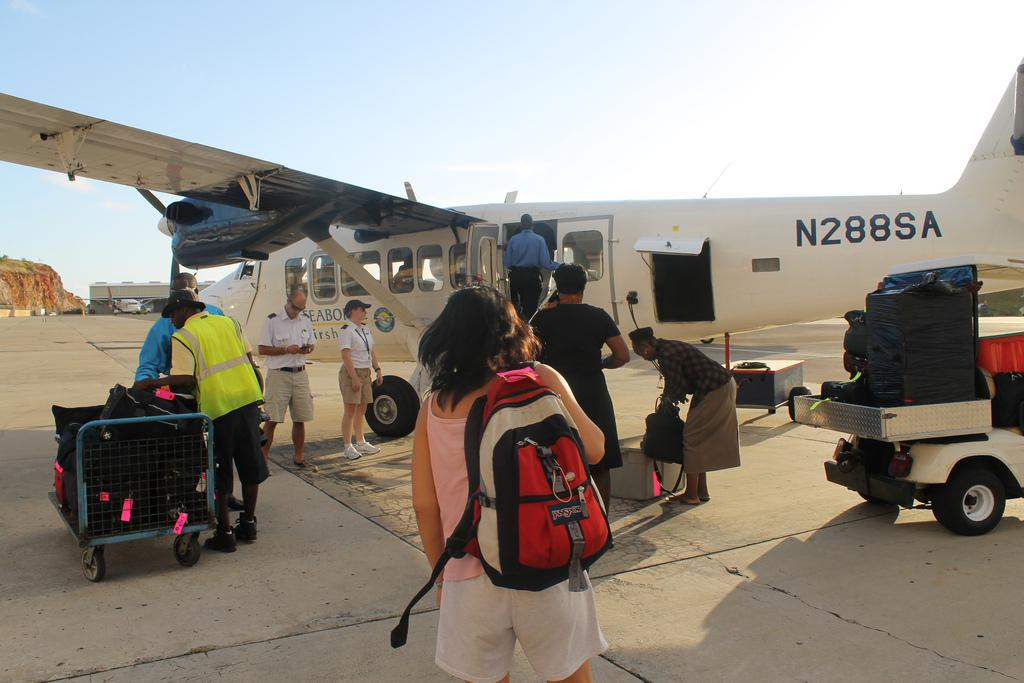Question: when does the scene take place?
Choices:
A. At 3 o'clock.
B. In the daytime.
C. At 4 o'clock.
D. At 5 o'clock.
Answer with the letter. Answer: B Question: who is wearing the yellow vest?
Choices:
A. Crossing guard.
B. Construction worker.
C. Safety patrol member.
D. Baggage handler.
Answer with the letter. Answer: D Question: where is this located?
Choices:
A. Grand Canyon.
B. New York City.
C. Airport.
D. La Guardia Airport.
Answer with the letter. Answer: C Question: what color is the plane?
Choices:
A. Teal.
B. Purple.
C. Neon.
D. White.
Answer with the letter. Answer: D Question: who is wearing khaki shorts?
Choices:
A. The class.
B. The employees.
C. The flight crew.
D. The lifeguards.
Answer with the letter. Answer: C Question: why does the man wear a yellow vest?
Choices:
A. For safety.
B. It is required.
C. To be noticeable.
D. He likes it.
Answer with the letter. Answer: A Question: how does the closest woman carry essential items?
Choices:
A. In her purse.
B. In her backpack.
C. In a tote bag.
D. In her pocket.
Answer with the letter. Answer: B Question: what color shirt is the man on the plane wearing?
Choices:
A. Black.
B. Blue.
C. Brown.
D. White.
Answer with the letter. Answer: B Question: what color backpack is the woman carrying?
Choices:
A. Blue.
B. Black.
C. Green.
D. Red.
Answer with the letter. Answer: D Question: what vehicles are shown?
Choices:
A. Luggage cart and airplane.
B. Trucks.
C. Baggage movers.
D. Jeeps.
Answer with the letter. Answer: A Question: what is the plane's number?
Choices:
A. F16.
B. N288sa.
C. B21.
D. B58.
Answer with the letter. Answer: B Question: who is in a blue shirt?
Choices:
A. Woman.
B. Chimpanzee.
C. Boy.
D. Man.
Answer with the letter. Answer: D Question: what has a Jansport label?
Choices:
A. The boy's shirt.
B. The boy's hat.
C. The girl's backpack.
D. The boy's backpack.
Answer with the letter. Answer: C Question: who has her back turned?
Choices:
A. The bride.
B. The carpenter.
C. A person.
D. The doctor.
Answer with the letter. Answer: C Question: where is the luggage?
Choices:
A. In his hand.
B. She is carrying it.
C. In the trunk.
D. On a cart.
Answer with the letter. Answer: D Question: how many clouds are in the sky?
Choices:
A. One.
B. Two.
C. Three.
D. Minimal.
Answer with the letter. Answer: D Question: what has blue writing on the side?
Choices:
A. The truck.
B. The plane.
C. The bus.
D. The sign.
Answer with the letter. Answer: B 